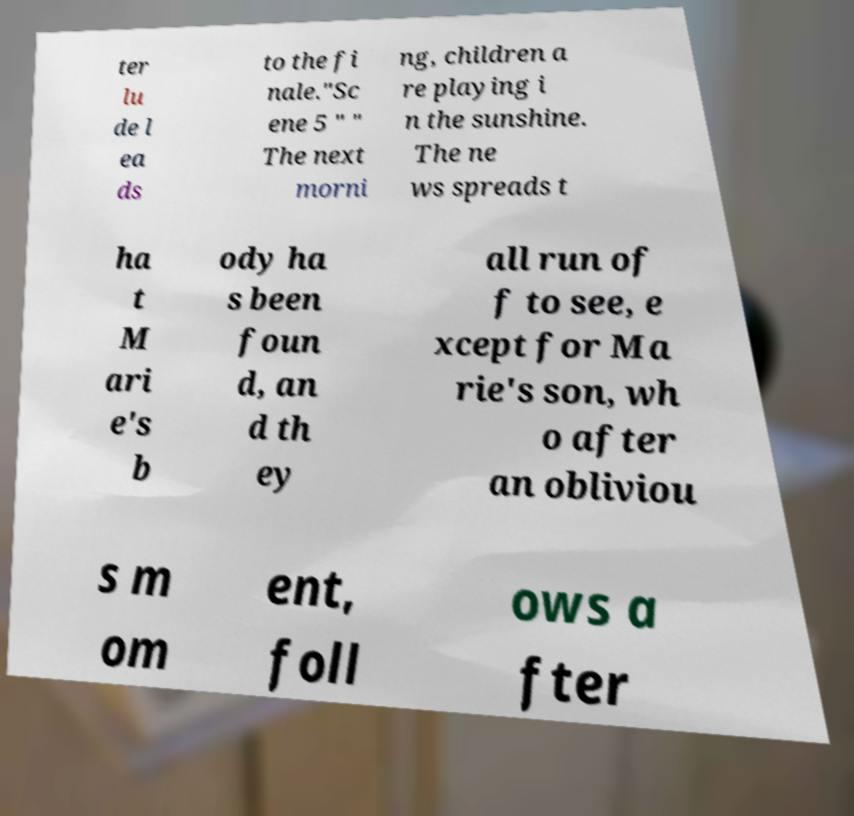Can you accurately transcribe the text from the provided image for me? ter lu de l ea ds to the fi nale."Sc ene 5 " " The next morni ng, children a re playing i n the sunshine. The ne ws spreads t ha t M ari e's b ody ha s been foun d, an d th ey all run of f to see, e xcept for Ma rie's son, wh o after an obliviou s m om ent, foll ows a fter 